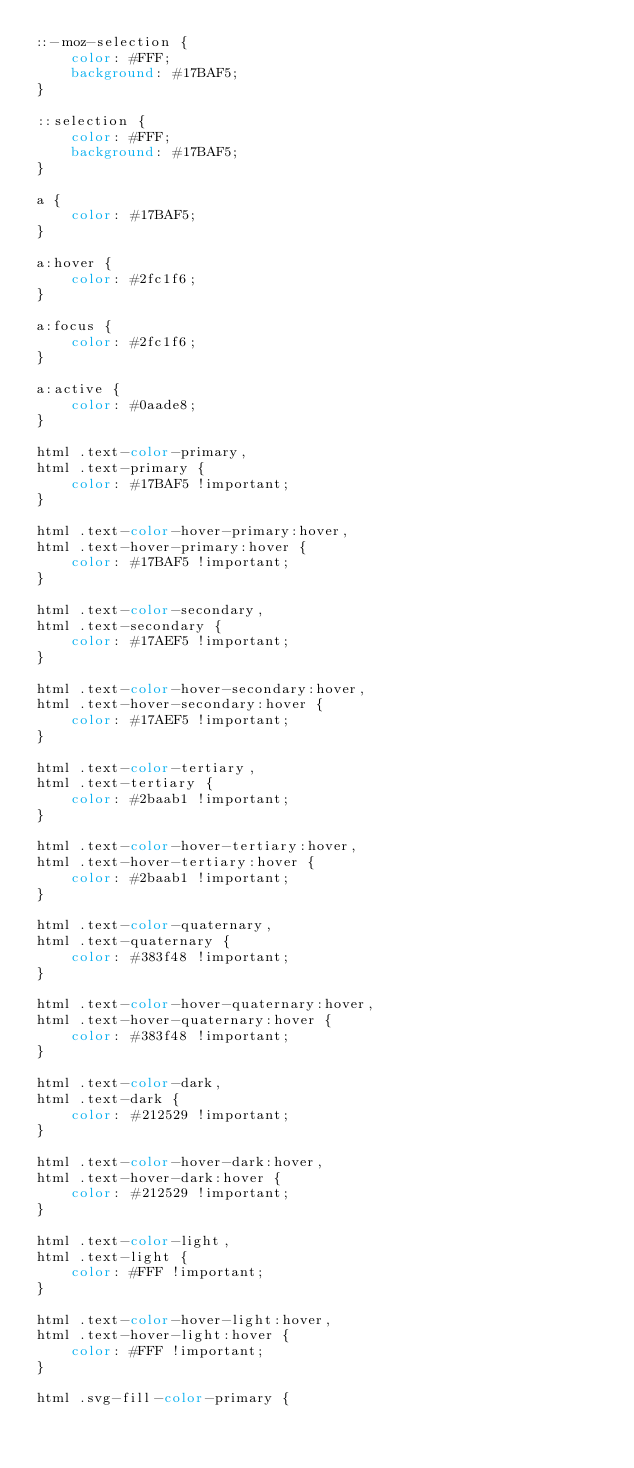Convert code to text. <code><loc_0><loc_0><loc_500><loc_500><_CSS_>::-moz-selection {
	color: #FFF;
	background: #17BAF5;
}

::selection {
	color: #FFF;
	background: #17BAF5;
}

a {
	color: #17BAF5;
}

a:hover {
	color: #2fc1f6;
}

a:focus {
	color: #2fc1f6;
}

a:active {
	color: #0aade8;
}

html .text-color-primary,
html .text-primary {
	color: #17BAF5 !important;
}

html .text-color-hover-primary:hover,
html .text-hover-primary:hover {
	color: #17BAF5 !important;
}

html .text-color-secondary,
html .text-secondary {
	color: #17AEF5 !important;
}

html .text-color-hover-secondary:hover,
html .text-hover-secondary:hover {
	color: #17AEF5 !important;
}

html .text-color-tertiary,
html .text-tertiary {
	color: #2baab1 !important;
}

html .text-color-hover-tertiary:hover,
html .text-hover-tertiary:hover {
	color: #2baab1 !important;
}

html .text-color-quaternary,
html .text-quaternary {
	color: #383f48 !important;
}

html .text-color-hover-quaternary:hover,
html .text-hover-quaternary:hover {
	color: #383f48 !important;
}

html .text-color-dark,
html .text-dark {
	color: #212529 !important;
}

html .text-color-hover-dark:hover,
html .text-hover-dark:hover {
	color: #212529 !important;
}

html .text-color-light,
html .text-light {
	color: #FFF !important;
}

html .text-color-hover-light:hover,
html .text-hover-light:hover {
	color: #FFF !important;
}

html .svg-fill-color-primary {</code> 